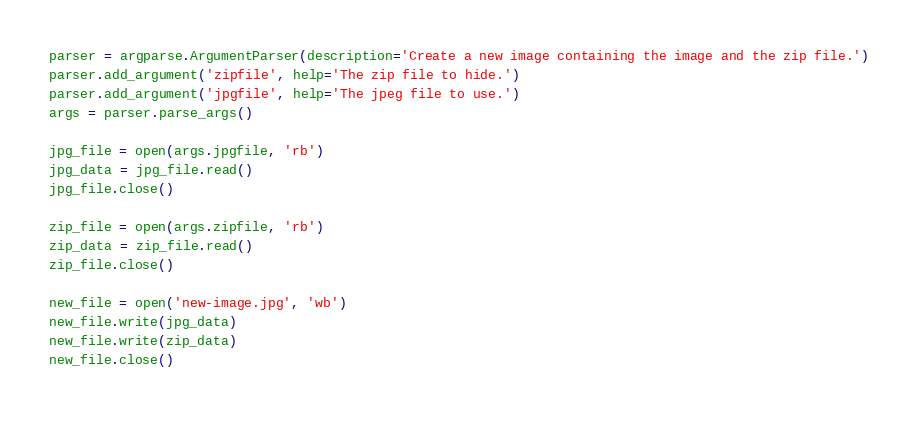Convert code to text. <code><loc_0><loc_0><loc_500><loc_500><_Python_>parser = argparse.ArgumentParser(description='Create a new image containing the image and the zip file.')
parser.add_argument('zipfile', help='The zip file to hide.')
parser.add_argument('jpgfile', help='The jpeg file to use.')
args = parser.parse_args()

jpg_file = open(args.jpgfile, 'rb')
jpg_data = jpg_file.read()
jpg_file.close()

zip_file = open(args.zipfile, 'rb')
zip_data = zip_file.read()
zip_file.close()

new_file = open('new-image.jpg', 'wb')
new_file.write(jpg_data)
new_file.write(zip_data)
new_file.close()</code> 